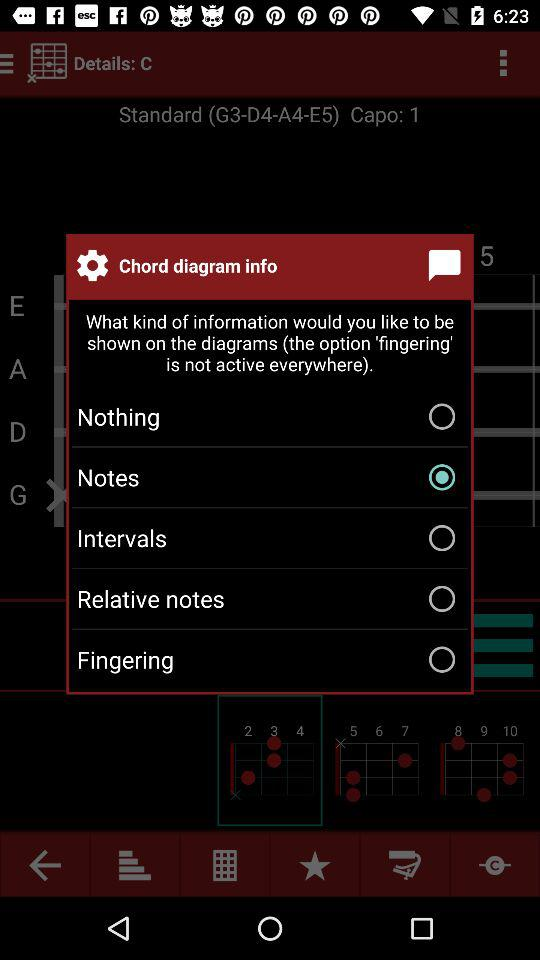Which option is selected for chord diagram information? The selected option for chord diagram information is "Notes". 